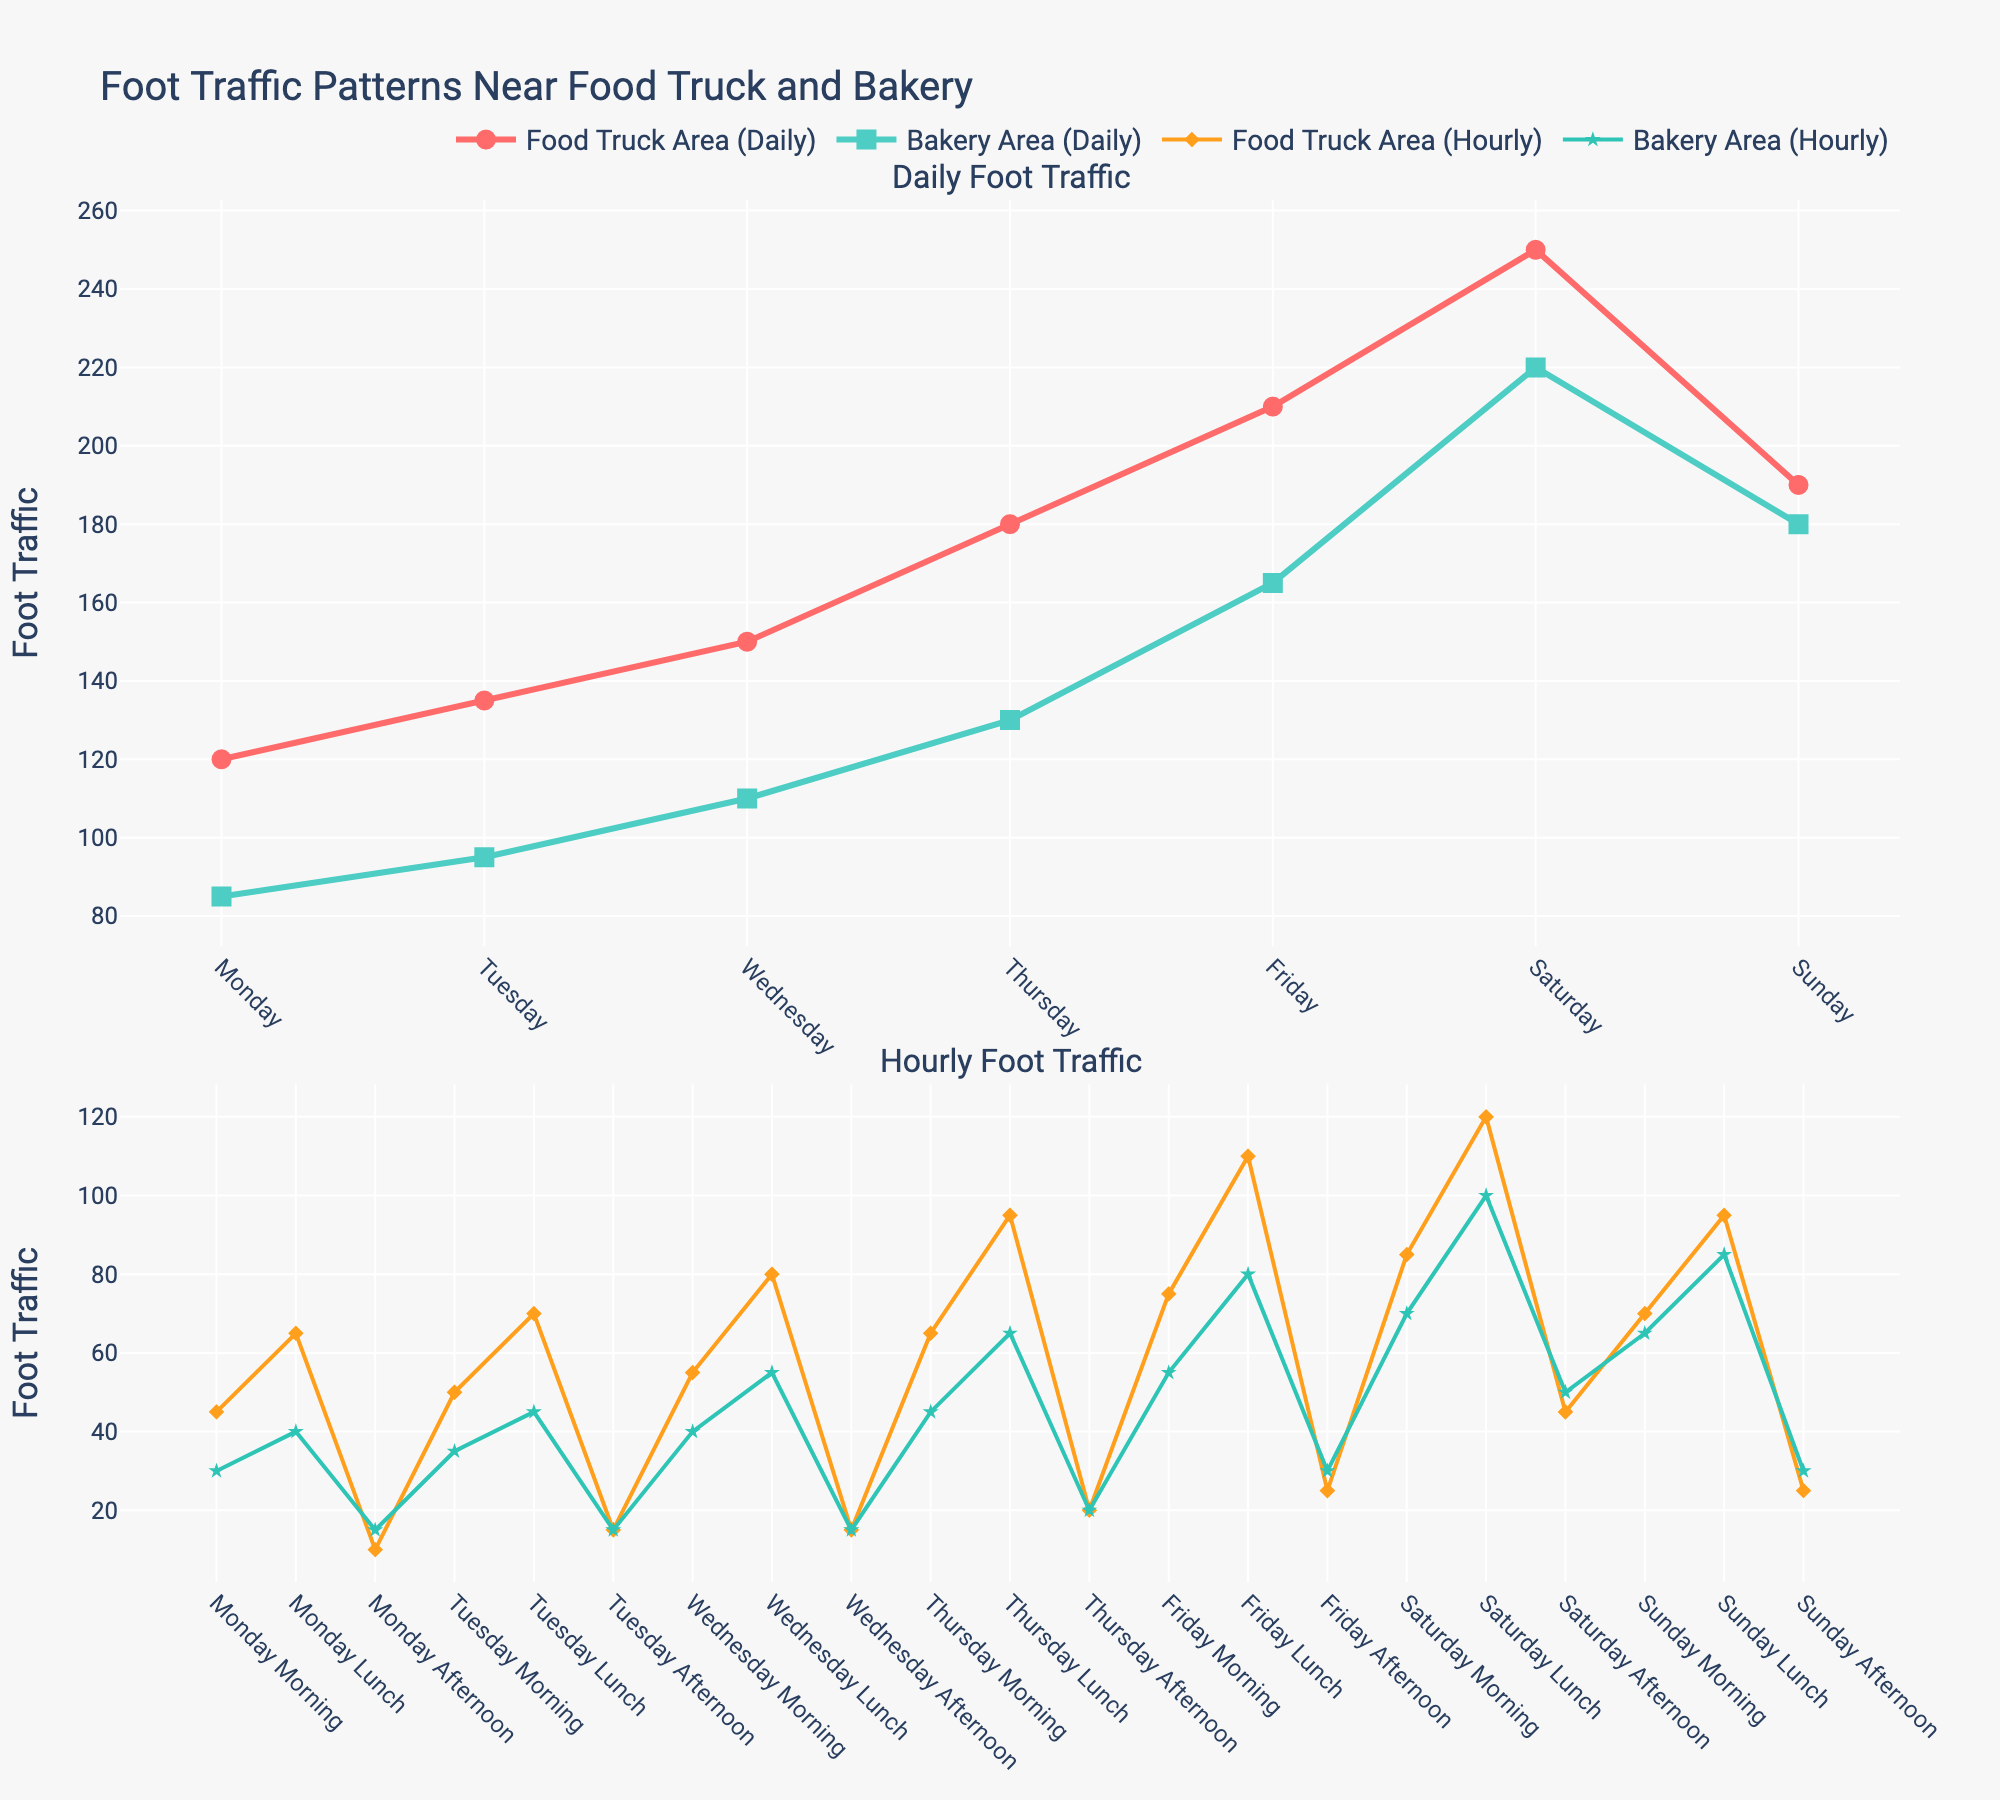Which day has the highest foot traffic in both the food truck and bakery areas? To find the day with the highest foot traffic in both areas, we look for the peak points on the line charts for each area. The Food Truck Area peaks at 250 on Saturday, and the Bakery Area peaks at 220 on Saturday as well.
Answer: Saturday What is the total foot traffic in the bakery area on weekdays? Weekdays include Monday to Friday. Summing up the traffic: 85 (Monday) + 95 (Tuesday) + 110 (Wednesday) + 130 (Thursday) + 165 (Friday), the total is 585.
Answer: 585 On which day is the difference in foot traffic between the food truck area and bakery area the least? The difference is smallest when the lines representing foot traffic in both areas are closest together. By inspecting closeness, Sunday has the smallest gap with 190 (Food Truck) and 180 (Bakery). The difference is 10.
Answer: Sunday Which time of day shows the highest foot traffic in the bakery area during lunch hours? Lunch hours are indicated by the specific labels "(Lunch)". Examining Bakery Area values: Monday Lunch (40), Tuesday Lunch (45), Wednesday Lunch (55), Thursday Lunch (65), Friday Lunch (80), Saturday Lunch (100), and Sunday Lunch (85). The highest is 100 on Saturday.
Answer: Saturday Lunch What is the average food truck area foot traffic during afternoons? To find the average, consider Monday Afternoon (10), Tuesday Afternoon (15), Wednesday Afternoon (15), Thursday Afternoon (20), Friday Afternoon (25), Saturday Afternoon (45), and Sunday Afternoon (25). The sum is 10+15+15+20+25+45+25 = 155. The average is 155/7 ≈ 22.14.
Answer: 22.14 Are there more people in the food truck area or the bakery area on Friday morning? For Friday Morning, compare the values in the charts: 75 (Food Truck) and 55 (Bakery). The food truck area has higher foot traffic.
Answer: Food Truck Area What is the visual difference between the food truck area and bakery area lines on a daily basis? The lines for daily foot traffic in the Food Truck Area appear in red with larger circle markers, while the Bakery Area lines are green with square markers.
Answer: Red circles vs. Green squares Which day shows the largest increase in foot traffic from the previous day in the food truck area? Analyzing day-to-day increases: Monday to Tuesday (+15), Tuesday to Wednesday (+15), Wednesday to Thursday (+30), Thursday to Friday (+30), Friday to Saturday (+40), Saturday to Sunday (-60). The largest increase is from Friday to Saturday, which is +40.
Answer: Friday to Saturday What is the difference in afternoon foot traffic between the food truck area and bakery area on Wednesday? For Wednesday Afternoon, the values are 15 (Food Truck) and 15 (Bakery). The difference is
Answer: 0 By how much does the foot traffic increase from Monday morning to Monday lunch in the food truck area? For Monday, Morning traffic is 45, and Lunch traffic is 65. The increase is 65 - 45 = 20.
Answer: 20 